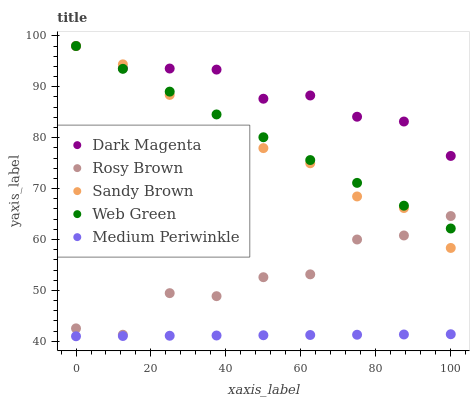Does Medium Periwinkle have the minimum area under the curve?
Answer yes or no. Yes. Does Dark Magenta have the maximum area under the curve?
Answer yes or no. Yes. Does Rosy Brown have the minimum area under the curve?
Answer yes or no. No. Does Rosy Brown have the maximum area under the curve?
Answer yes or no. No. Is Medium Periwinkle the smoothest?
Answer yes or no. Yes. Is Rosy Brown the roughest?
Answer yes or no. Yes. Is Sandy Brown the smoothest?
Answer yes or no. No. Is Sandy Brown the roughest?
Answer yes or no. No. Does Medium Periwinkle have the lowest value?
Answer yes or no. Yes. Does Rosy Brown have the lowest value?
Answer yes or no. No. Does Web Green have the highest value?
Answer yes or no. Yes. Does Rosy Brown have the highest value?
Answer yes or no. No. Is Medium Periwinkle less than Rosy Brown?
Answer yes or no. Yes. Is Dark Magenta greater than Rosy Brown?
Answer yes or no. Yes. Does Rosy Brown intersect Web Green?
Answer yes or no. Yes. Is Rosy Brown less than Web Green?
Answer yes or no. No. Is Rosy Brown greater than Web Green?
Answer yes or no. No. Does Medium Periwinkle intersect Rosy Brown?
Answer yes or no. No. 